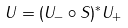Convert formula to latex. <formula><loc_0><loc_0><loc_500><loc_500>U = ( U _ { - } \circ S ) ^ { * } U _ { + }</formula> 